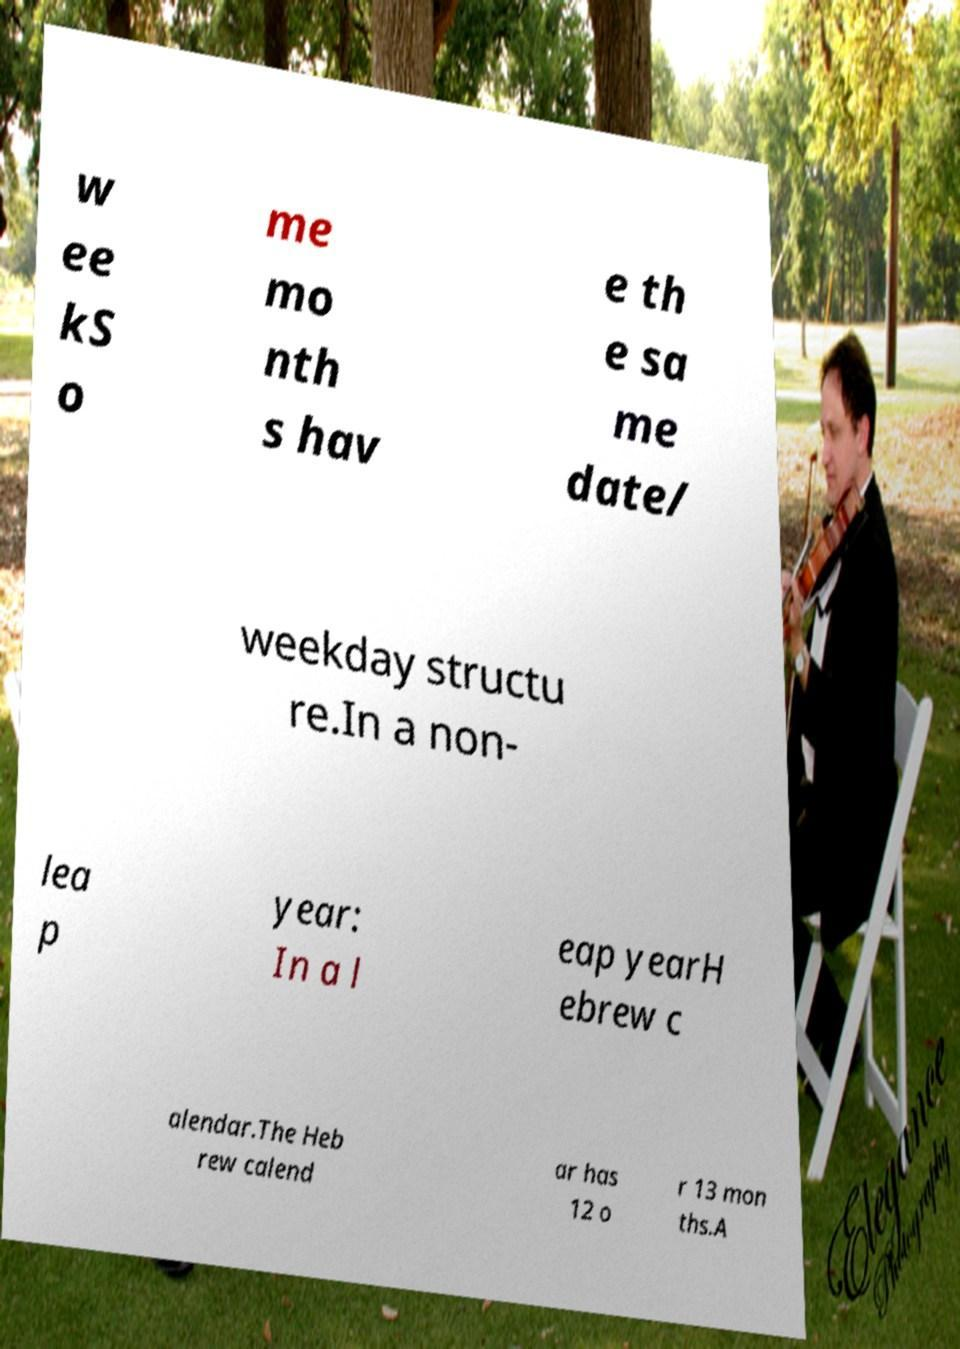There's text embedded in this image that I need extracted. Can you transcribe it verbatim? w ee kS o me mo nth s hav e th e sa me date/ weekday structu re.In a non- lea p year: In a l eap yearH ebrew c alendar.The Heb rew calend ar has 12 o r 13 mon ths.A 